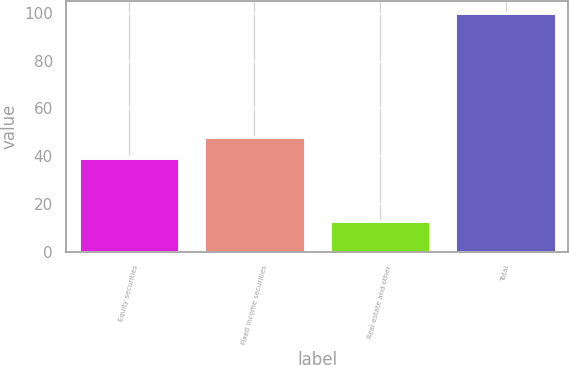<chart> <loc_0><loc_0><loc_500><loc_500><bar_chart><fcel>Equity securities<fcel>Fixed income securities<fcel>Real estate and other<fcel>Total<nl><fcel>39<fcel>48<fcel>13<fcel>100<nl></chart> 